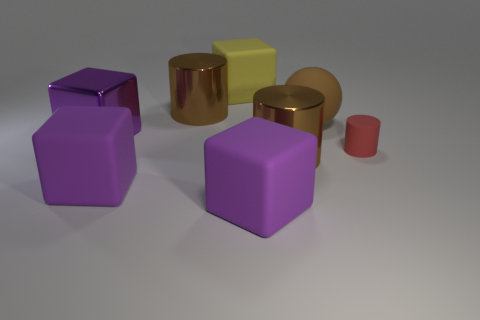Subtract all rubber cylinders. How many cylinders are left? 2 Subtract all yellow blocks. How many blocks are left? 3 Subtract all yellow cylinders. How many purple cubes are left? 3 Add 1 tiny red cylinders. How many objects exist? 9 Subtract 3 cubes. How many cubes are left? 1 Add 8 large red metallic blocks. How many large red metallic blocks exist? 8 Subtract 0 green cylinders. How many objects are left? 8 Subtract all spheres. How many objects are left? 7 Subtract all gray cylinders. Subtract all cyan blocks. How many cylinders are left? 3 Subtract all rubber cubes. Subtract all purple matte cubes. How many objects are left? 3 